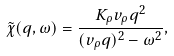Convert formula to latex. <formula><loc_0><loc_0><loc_500><loc_500>\tilde { \chi } ( q , \omega ) = \frac { K _ { \rho } v _ { \rho } q ^ { 2 } } { ( v _ { \rho } q ) ^ { 2 } - \omega ^ { 2 } } ,</formula> 